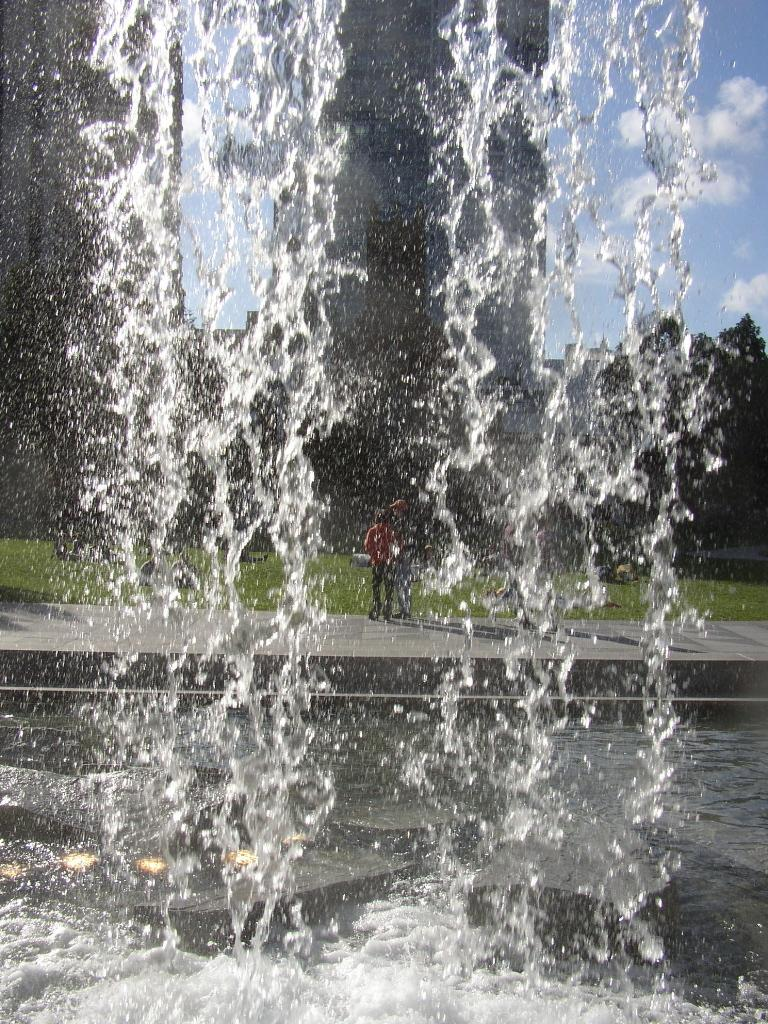What is the main subject in the center of the image? There is a water fountain in the center of the image. What can be seen in the background of the image? There are buildings, persons, trees, and the sky visible in the background of the image. Are there any clouds in the sky? Yes, there are clouds in the sky. What time of day is represented in the image? The image does not depict a specific time of day, so it cannot be determined whether it is morning or any other time. 